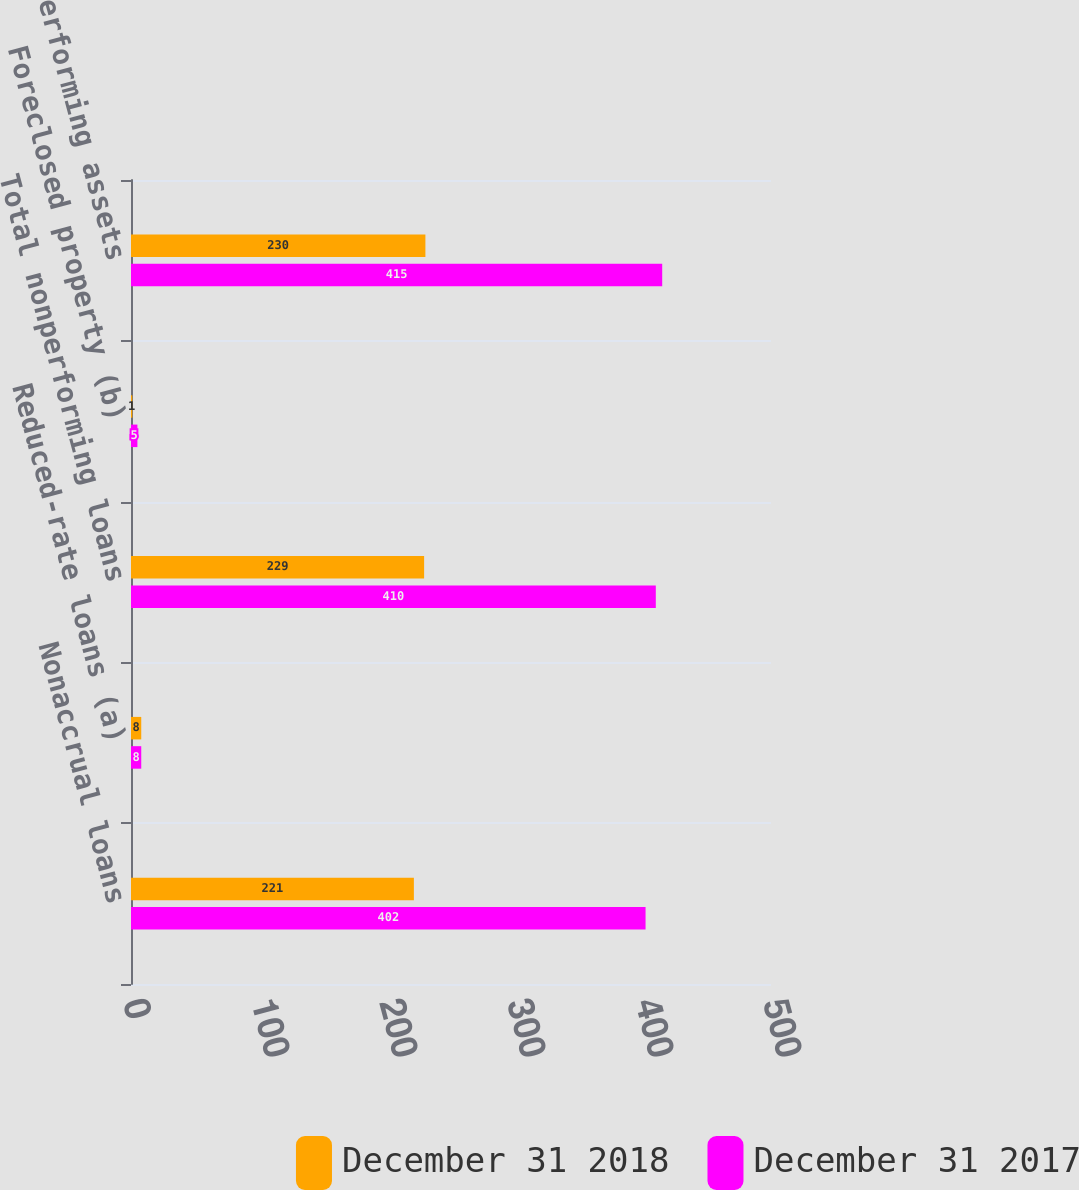Convert chart. <chart><loc_0><loc_0><loc_500><loc_500><stacked_bar_chart><ecel><fcel>Nonaccrual loans<fcel>Reduced-rate loans (a)<fcel>Total nonperforming loans<fcel>Foreclosed property (b)<fcel>Total nonperforming assets<nl><fcel>December 31 2018<fcel>221<fcel>8<fcel>229<fcel>1<fcel>230<nl><fcel>December 31 2017<fcel>402<fcel>8<fcel>410<fcel>5<fcel>415<nl></chart> 